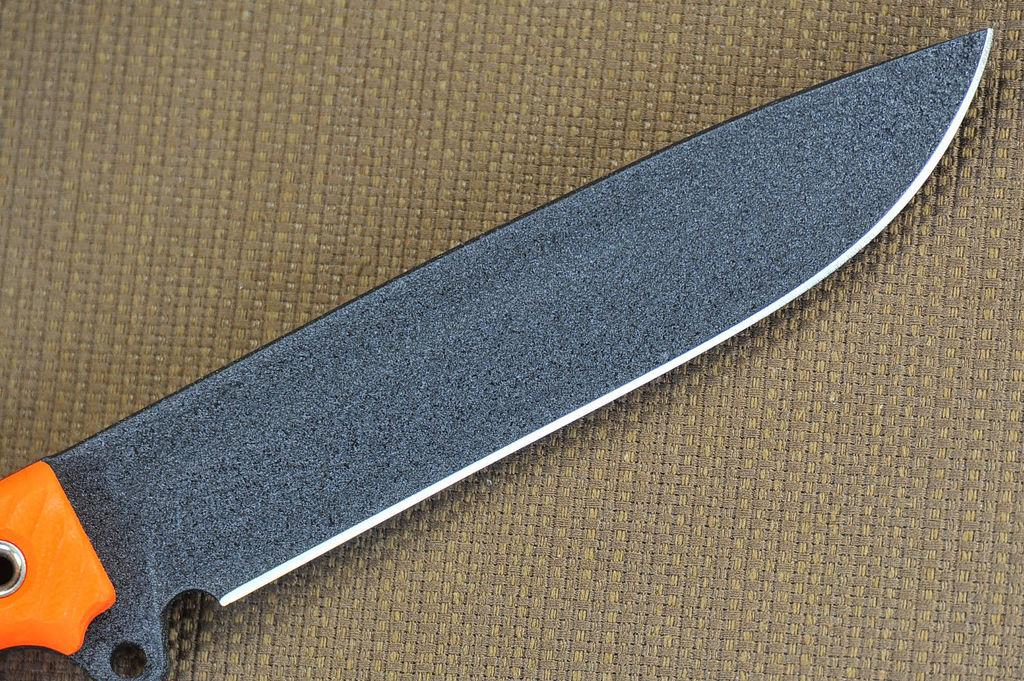What is the focus of the image? The image is zoomed in on a knife. Can you describe the knife in the image? The knife in the center of the image is orange in color. What is the knife placed on in the image? The knife is placed on a brown color object. How many apples are visible in the image? There are no apples present in the image. What type of zebra can be seen interacting with the knife in the image? There is no zebra present in the image, and therefore no such interaction can be observed. 